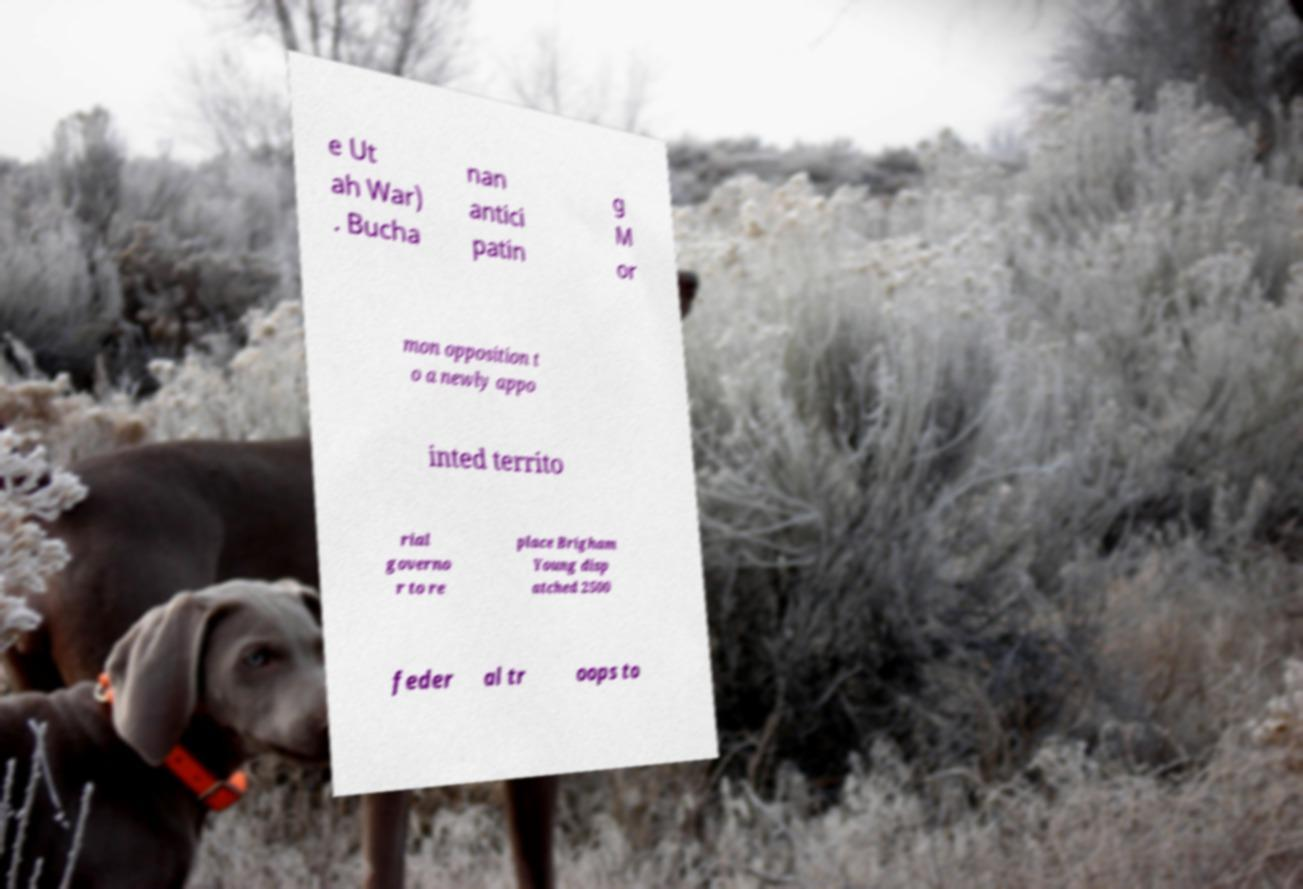Can you accurately transcribe the text from the provided image for me? e Ut ah War) . Bucha nan antici patin g M or mon opposition t o a newly appo inted territo rial governo r to re place Brigham Young disp atched 2500 feder al tr oops to 